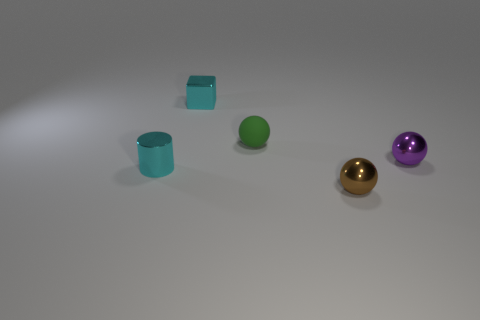Subtract all tiny brown balls. How many balls are left? 2 Add 5 shiny cylinders. How many objects exist? 10 Subtract all balls. How many objects are left? 2 Subtract all small brown spheres. Subtract all purple metallic balls. How many objects are left? 3 Add 4 purple things. How many purple things are left? 5 Add 4 green objects. How many green objects exist? 5 Subtract 0 green cubes. How many objects are left? 5 Subtract all gray balls. Subtract all yellow cylinders. How many balls are left? 3 